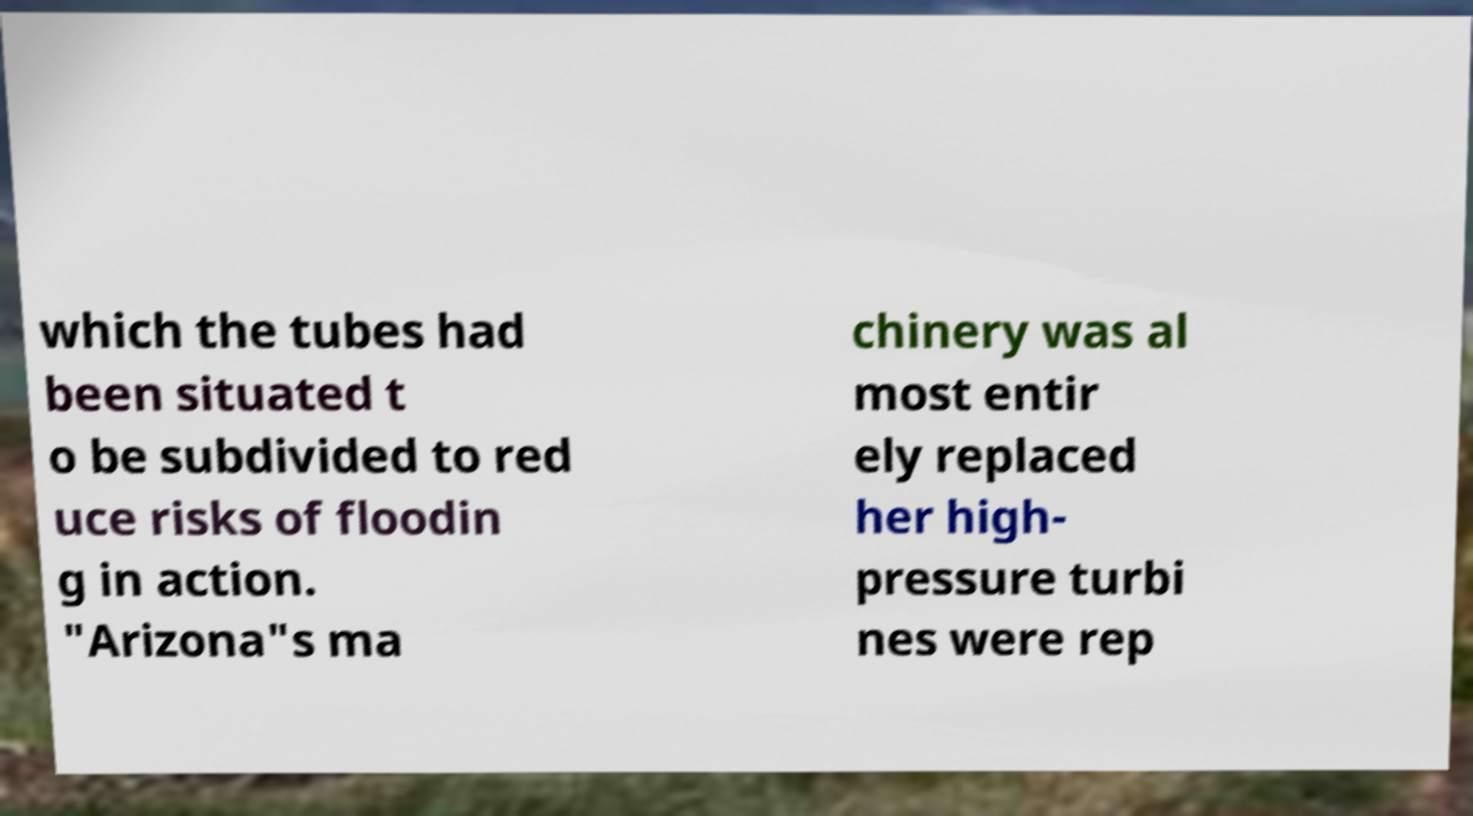Can you read and provide the text displayed in the image?This photo seems to have some interesting text. Can you extract and type it out for me? which the tubes had been situated t o be subdivided to red uce risks of floodin g in action. "Arizona"s ma chinery was al most entir ely replaced her high- pressure turbi nes were rep 